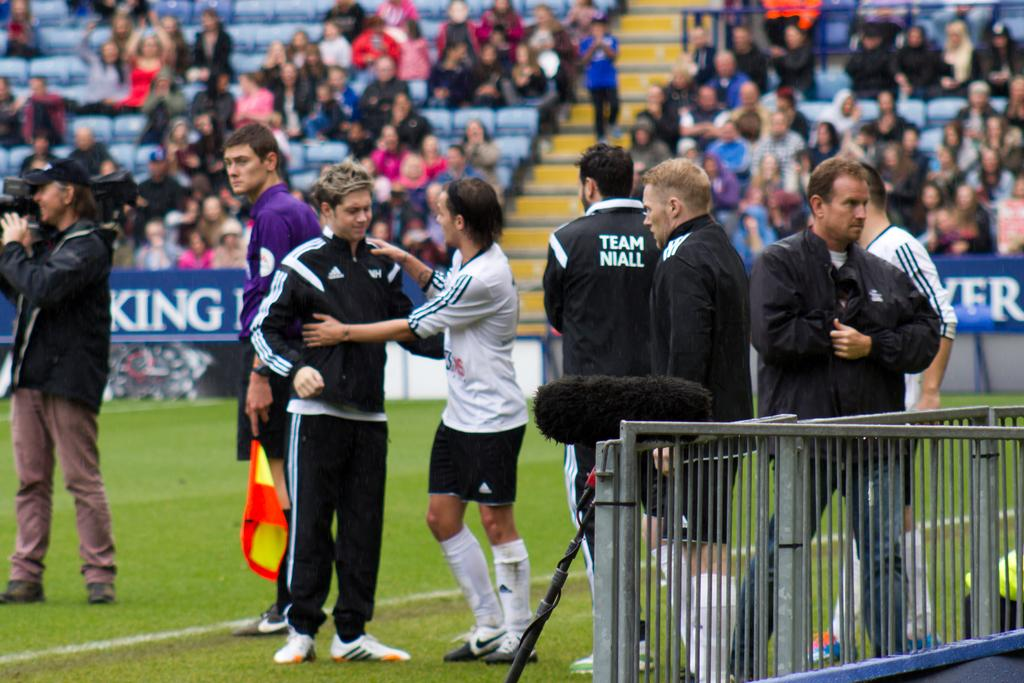What are the people in the center of the image doing? The people in the center of the image are standing. What is the man on the left holding? The man on the left is holding a camera. What can be seen in the background of the image? There is a crowd in the background of the image. What is located on the right side of the image? There is a fence on the right side of the image. What type of banana is being used to cause a commotion in the image? There is no banana present in the image, nor is there any commotion taking place. 